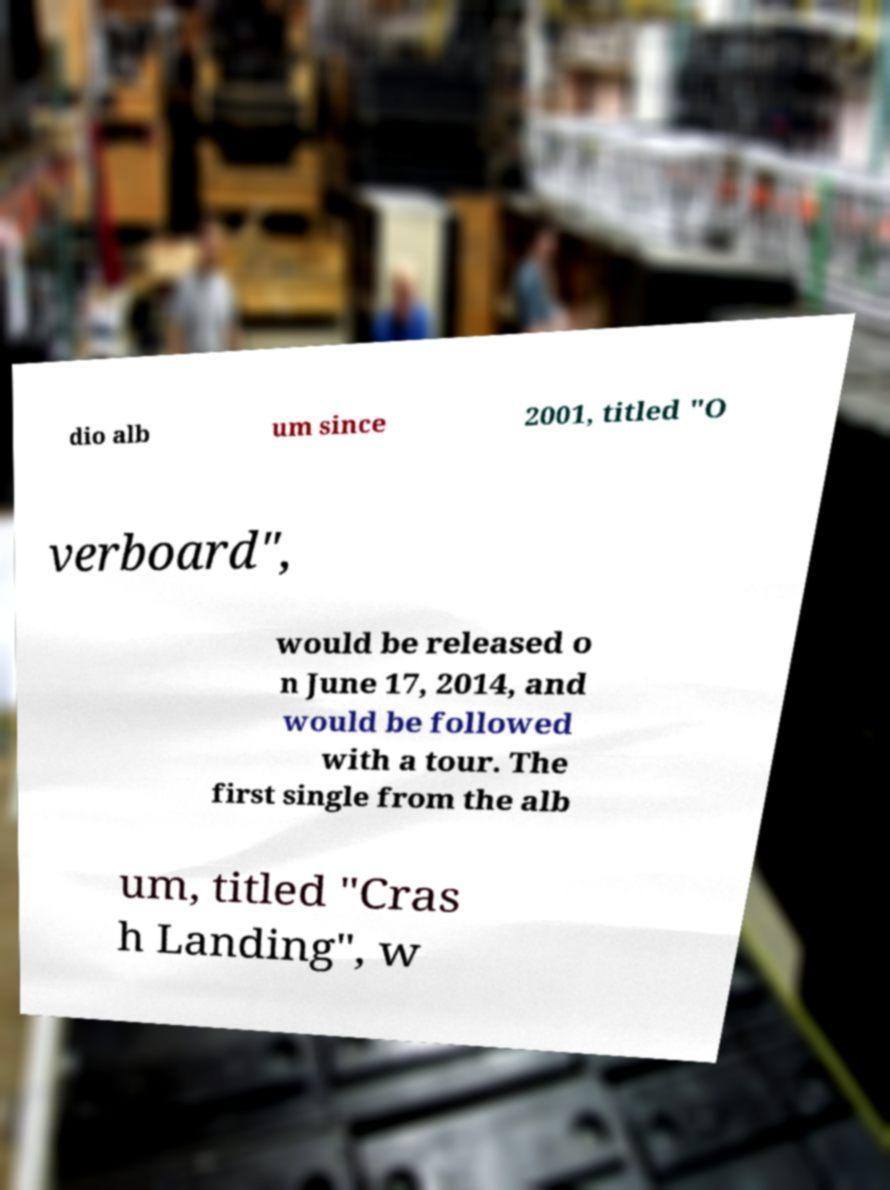Please identify and transcribe the text found in this image. dio alb um since 2001, titled "O verboard", would be released o n June 17, 2014, and would be followed with a tour. The first single from the alb um, titled "Cras h Landing", w 